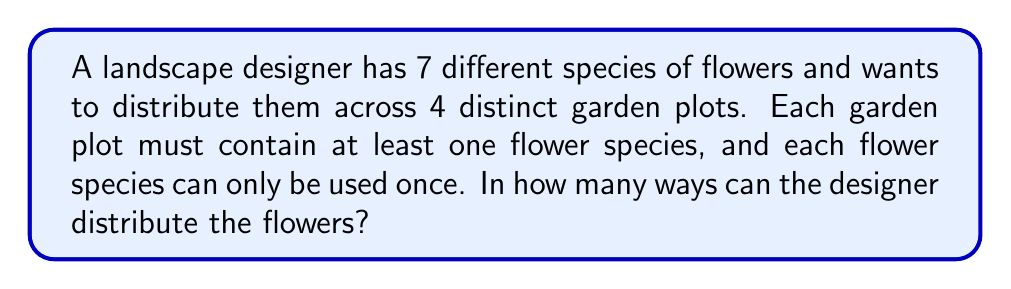Provide a solution to this math problem. Let's approach this step-by-step:

1) This is a problem of distributing distinct objects (7 flower species) into distinct boxes (4 garden plots) with restrictions.

2) We can use the concept of Stirling numbers of the second kind, denoted as $\stirling{n}{k}$, which count the number of ways to partition n distinct objects into k non-empty subsets.

3) However, we need to consider that the garden plots are distinct. So after partitioning the flowers, we need to consider the number of ways to arrange these partitions among the plots.

4) The formula for this scenario is:

   $$k! \cdot \stirling{n}{k}$$

   where $n$ is the number of distinct objects and $k$ is the number of distinct boxes.

5) In our case, $n = 7$ (flower species) and $k = 4$ (garden plots).

6) The Stirling number $\stirling{7}{4}$ can be calculated as:

   $$\stirling{7}{4} = \frac{1}{24}(4^7 - 4 \cdot 3^7 + 6 \cdot 2^7 - 4 \cdot 1^7) = 350$$

7) Now we multiply this by $4!$ to account for the distinct arrangements of the partitions:

   $$4! \cdot \stirling{7}{4} = 24 \cdot 350 = 8400$$

Thus, there are 8400 ways to distribute the flowers.
Answer: 8400 